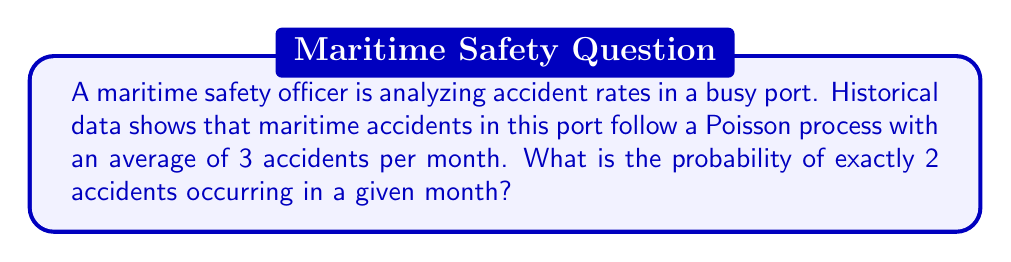Teach me how to tackle this problem. To solve this problem, we'll use the Poisson probability mass function:

$$P(X = k) = \frac{e^{-\lambda} \lambda^k}{k!}$$

Where:
$\lambda$ = average rate of events (accidents per month)
$k$ = number of events we're interested in
$e$ = Euler's number (approximately 2.71828)

Given:
$\lambda = 3$ accidents per month
$k = 2$ accidents

Step 1: Substitute the values into the formula
$$P(X = 2) = \frac{e^{-3} 3^2}{2!}$$

Step 2: Calculate $3^2$
$$P(X = 2) = \frac{e^{-3} \cdot 9}{2!}$$

Step 3: Calculate 2!
$$P(X = 2) = \frac{e^{-3} \cdot 9}{2}$$

Step 4: Simplify
$$P(X = 2) = \frac{9e^{-3}}{2}$$

Step 5: Calculate $e^{-3}$ (use a calculator)
$$P(X = 2) = \frac{9 \cdot 0.0497870684}{2}$$

Step 6: Multiply and divide
$$P(X = 2) = 0.2240418076$$

Step 7: Round to 4 decimal places
$$P(X = 2) \approx 0.2240$$
Answer: 0.2240 